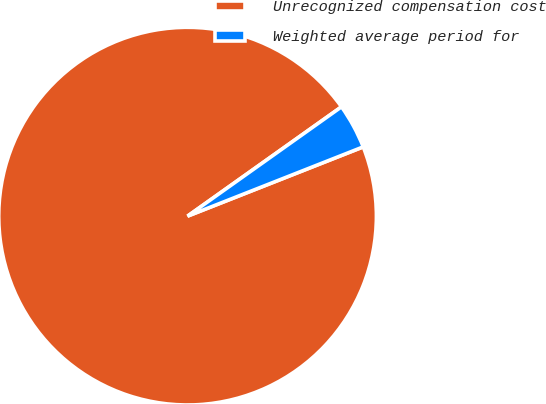Convert chart. <chart><loc_0><loc_0><loc_500><loc_500><pie_chart><fcel>Unrecognized compensation cost<fcel>Weighted average period for<nl><fcel>96.15%<fcel>3.85%<nl></chart> 